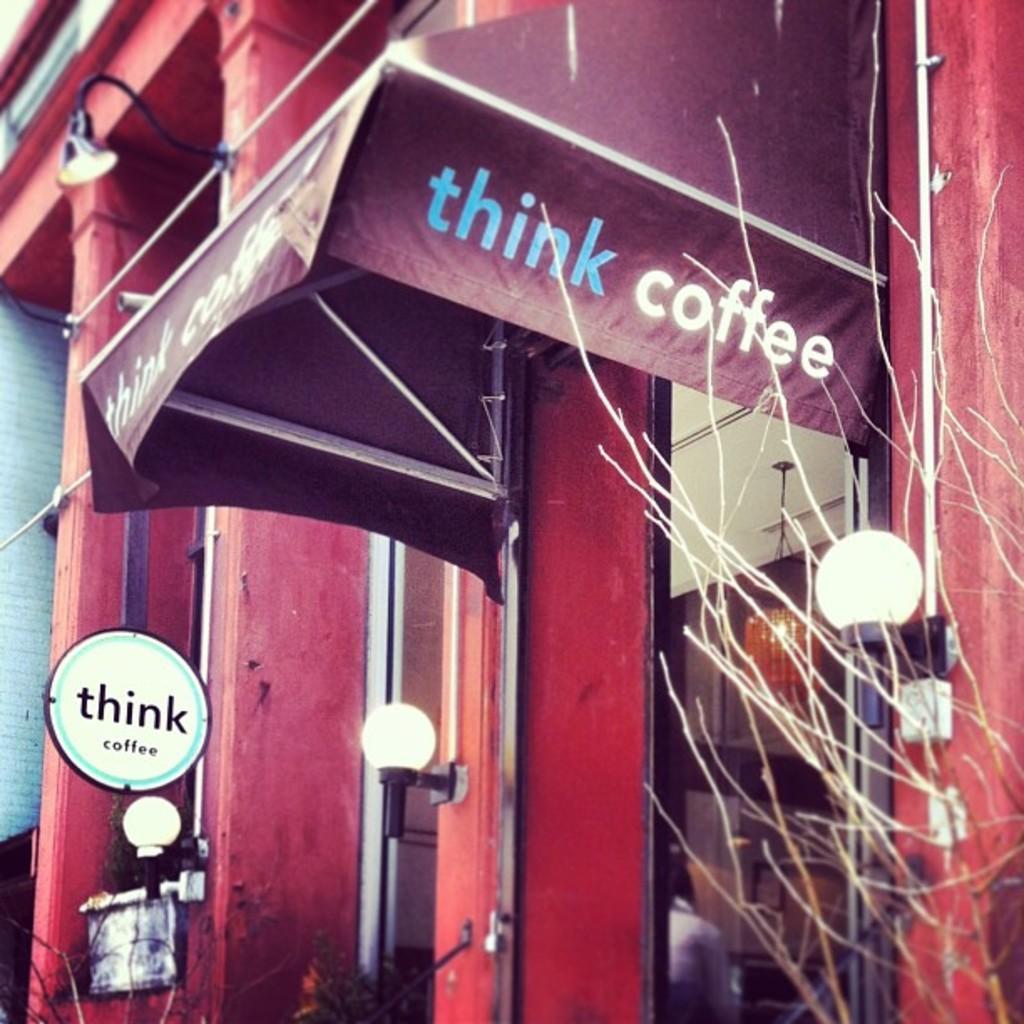Please provide a concise description of this image. In this image there is a building with lights in-front of that. 